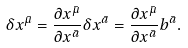<formula> <loc_0><loc_0><loc_500><loc_500>\delta x ^ { \bar { \mu } } = \frac { { \partial } x ^ { \bar { \mu } } } { { \partial } x ^ { \bar { a } } } \delta x ^ { \bar { a } } = \frac { { \partial } x ^ { \bar { \mu } } } { { \partial } x ^ { \bar { a } } } b ^ { \bar { a } } .</formula> 